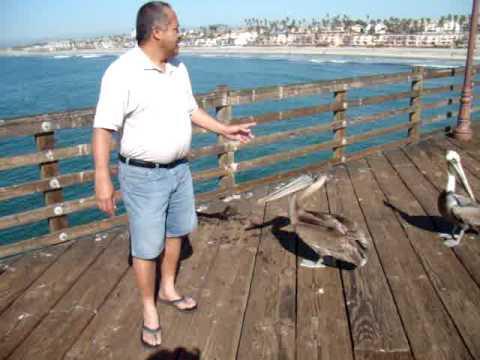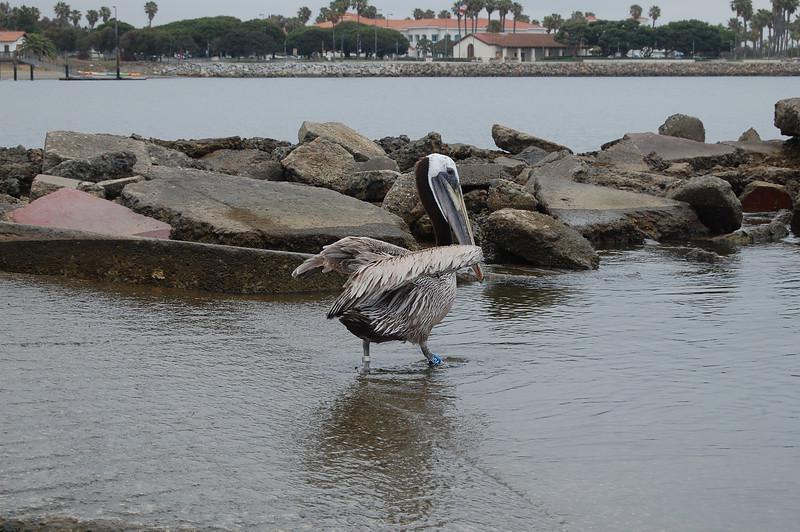The first image is the image on the left, the second image is the image on the right. Considering the images on both sides, is "At least one person is interacting with birds in one image." valid? Answer yes or no. Yes. The first image is the image on the left, the second image is the image on the right. For the images displayed, is the sentence "In one image, there is at least one person near a pelican." factually correct? Answer yes or no. Yes. 